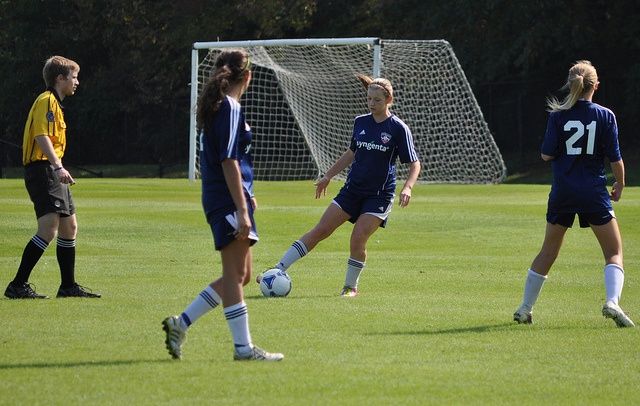Describe the objects in this image and their specific colors. I can see people in black, maroon, and gray tones, people in black and gray tones, people in black, gray, and maroon tones, people in black, gray, and olive tones, and sports ball in black, gray, and darkgray tones in this image. 